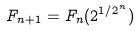Convert formula to latex. <formula><loc_0><loc_0><loc_500><loc_500>F _ { n + 1 } = F _ { n } ( 2 ^ { 1 / 2 ^ { n } } )</formula> 